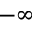Convert formula to latex. <formula><loc_0><loc_0><loc_500><loc_500>- \infty</formula> 